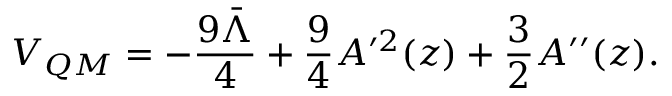Convert formula to latex. <formula><loc_0><loc_0><loc_500><loc_500>V _ { Q M } = - \frac { 9 \bar { \Lambda } } { 4 } + \frac { 9 } { 4 } A ^ { \prime 2 } ( z ) + \frac { 3 } { 2 } A ^ { \prime \prime } ( z ) .</formula> 